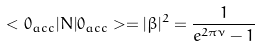Convert formula to latex. <formula><loc_0><loc_0><loc_500><loc_500>< 0 _ { a c c } | N | 0 _ { a c c } > = | \beta | ^ { 2 } = \frac { 1 } { e ^ { 2 \pi \nu } - 1 }</formula> 